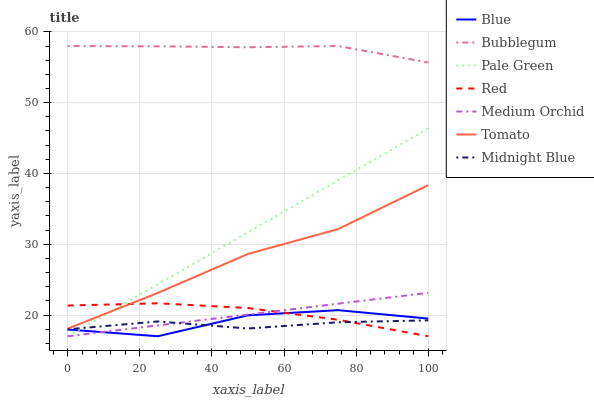Does Tomato have the minimum area under the curve?
Answer yes or no. No. Does Tomato have the maximum area under the curve?
Answer yes or no. No. Is Tomato the smoothest?
Answer yes or no. No. Is Tomato the roughest?
Answer yes or no. No. Does Tomato have the lowest value?
Answer yes or no. No. Does Tomato have the highest value?
Answer yes or no. No. Is Blue less than Bubblegum?
Answer yes or no. Yes. Is Bubblegum greater than Blue?
Answer yes or no. Yes. Does Blue intersect Bubblegum?
Answer yes or no. No. 